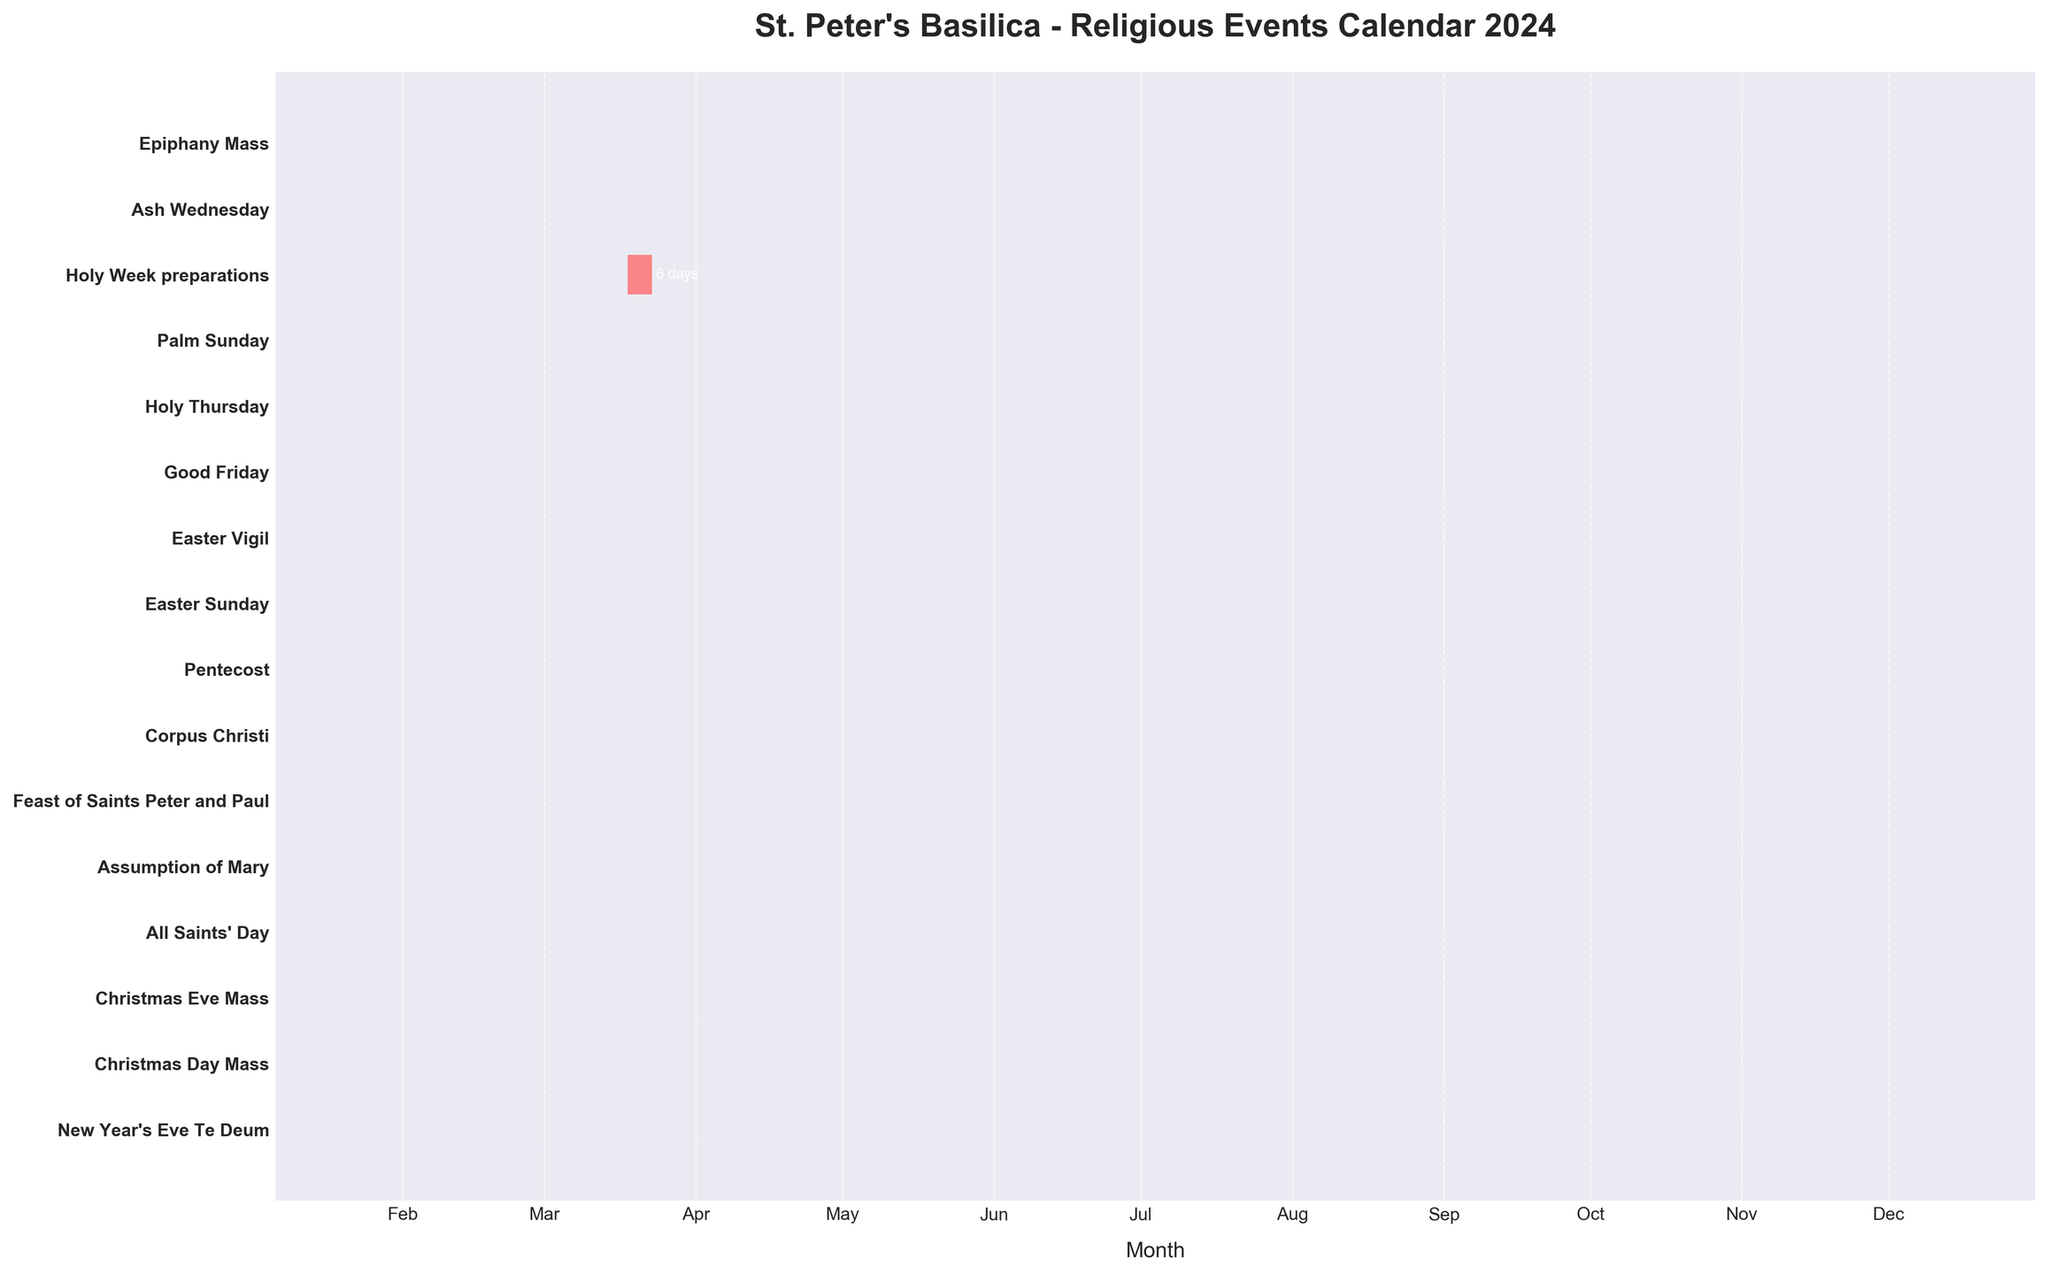what is the title of the chart? The title is located above the plot, indicating its main subject. It reads: "St. Peter's Basilica - Religious Events Calendar 2024".
Answer: St. Peter's Basilica - Religious Events Calendar 2024 Which event is the first in the year? The first event in the year is the one that starts the earliest according to the timeline presented on the x-axis. The event "Epiphany Mass" starts on January 6, which is the earliest date shown.
Answer: Epiphany Mass How many events occur in March? By examining the labels and the corresponding bars in March on the x-axis, three events can be identified in March: Holy Week preparations, Palm Sunday, Holy Thursday, Good Friday, Easter Vigil, and Easter Sunday, making it a total of six.
Answer: Six What event occurs immediately after Palm Sunday? By following the timeline and sequence of events, "Holy Thursday" occurs right after Palm Sunday.
Answer: Holy Thursday Which event spans the most days? The event with the longest duration can be identified by the length of its horizontal bar. "Holy Week preparations" spans six days from March 18 to March 23.
Answer: Holy Week preparations How many events are there in December? Checking the end of the year on the x-axis, December contains three events: Christmas Eve Mass, Christmas Day Mass, and New Year's Eve Te Deum.
Answer: Three Which event occurs in August? By checking the labels and their corresponding time in August on the x-axis, the "Assumption of Mary" is in August.
Answer: Assumption of Mary Which events are marked with the color red? All events use the same red color for their horizontal bars.
Answer: All events Does any event overlap with another one in the timeline? None of the bars representing the events visually overlap on the chart, indicating no events occur simultaneously.
Answer: No What is the duration of the Holy Week preparations? The Holy Week preparations span from March 18 to March 23. The difference is calculated as 23 - 18 + 1 = 6 days.
Answer: Six days 